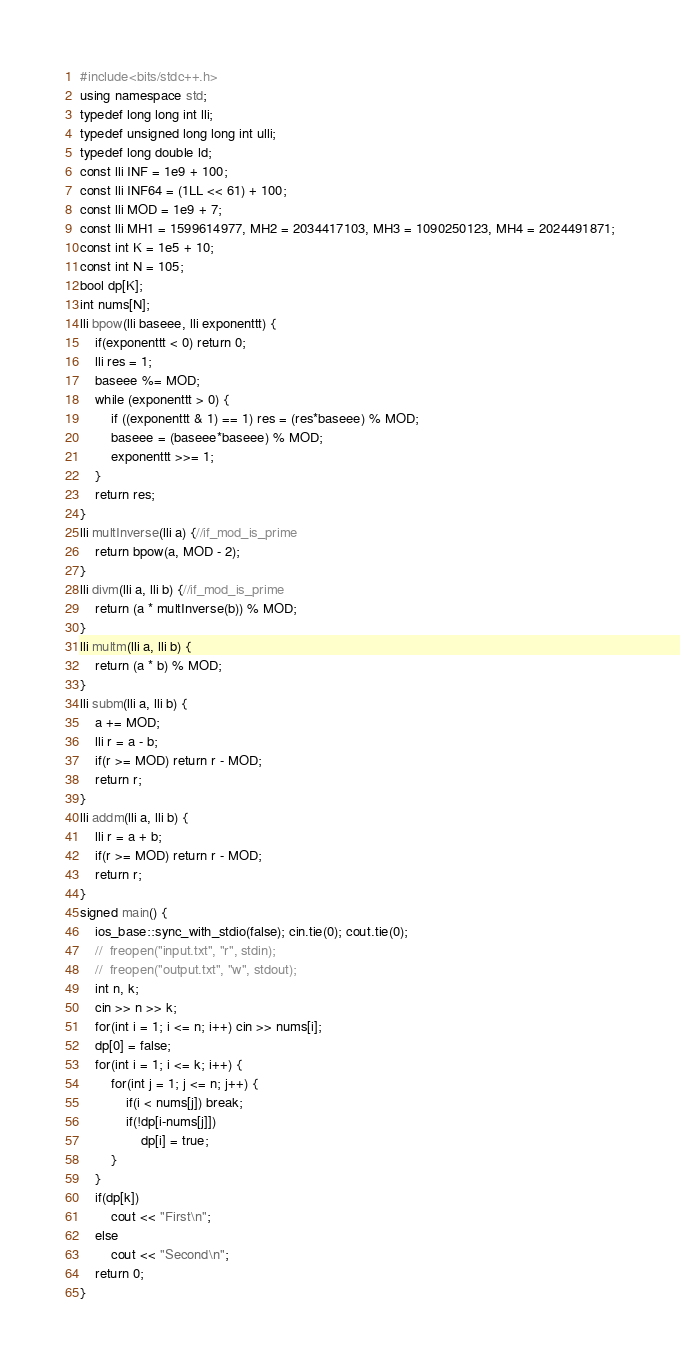<code> <loc_0><loc_0><loc_500><loc_500><_C++_>#include<bits/stdc++.h>
using namespace std;
typedef long long int lli;
typedef unsigned long long int ulli;
typedef long double ld;
const lli INF = 1e9 + 100;
const lli INF64 = (1LL << 61) + 100;
const lli MOD = 1e9 + 7;
const lli MH1 = 1599614977, MH2 = 2034417103, MH3 = 1090250123, MH4 = 2024491871;
const int K = 1e5 + 10;
const int N = 105;
bool dp[K];
int nums[N];
lli bpow(lli baseee, lli exponenttt) {
	if(exponenttt < 0) return 0;
	lli res = 1;
	baseee %= MOD;
	while (exponenttt > 0) {
		if ((exponenttt & 1) == 1) res = (res*baseee) % MOD;
		baseee = (baseee*baseee) % MOD;
		exponenttt >>= 1;
	}
	return res;
}
lli multInverse(lli a) {//if_mod_is_prime
	return bpow(a, MOD - 2);
}
lli divm(lli a, lli b) {//if_mod_is_prime
	return (a * multInverse(b)) % MOD;
}
lli multm(lli a, lli b) {
	return (a * b) % MOD;
}
lli subm(lli a, lli b) {
	a += MOD;
	lli r = a - b;
	if(r >= MOD) return r - MOD;
	return r;
}
lli addm(lli a, lli b) {
	lli r = a + b;
	if(r >= MOD) return r - MOD;
	return r;
}
signed main() {
	ios_base::sync_with_stdio(false); cin.tie(0); cout.tie(0);
	//	freopen("input.txt", "r", stdin);
	//	freopen("output.txt", "w", stdout);
	int n, k;
	cin >> n >> k;
	for(int i = 1; i <= n; i++) cin >> nums[i];
	dp[0] = false;
	for(int i = 1; i <= k; i++) {
		for(int j = 1; j <= n; j++) {
			if(i < nums[j]) break;
			if(!dp[i-nums[j]]) 
				dp[i] = true;
		}
	}
	if(dp[k])
		cout << "First\n";
	else	
		cout << "Second\n";
	return 0;
}</code> 